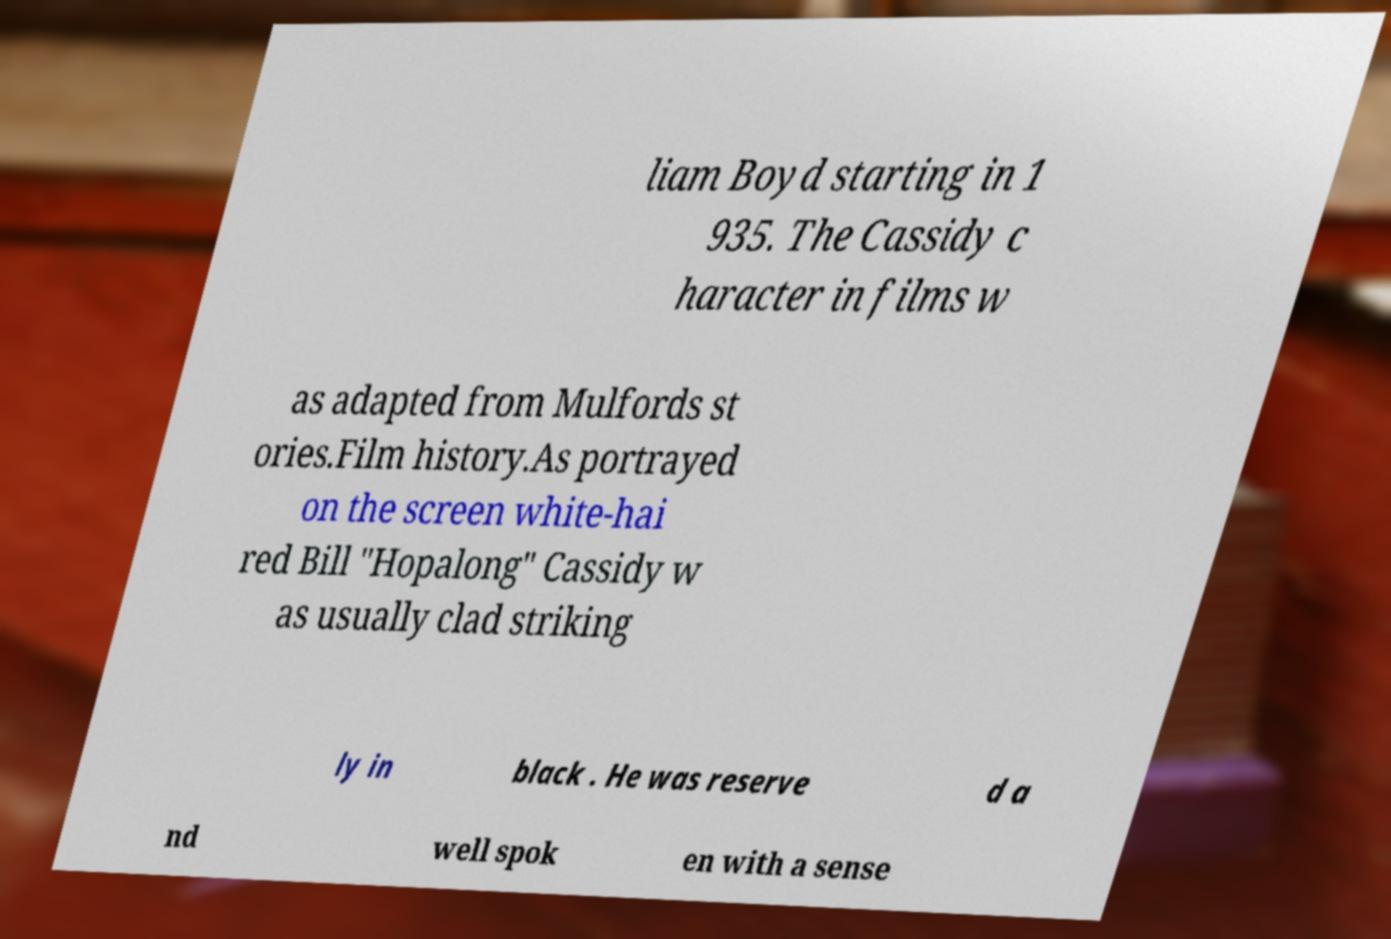Can you read and provide the text displayed in the image?This photo seems to have some interesting text. Can you extract and type it out for me? liam Boyd starting in 1 935. The Cassidy c haracter in films w as adapted from Mulfords st ories.Film history.As portrayed on the screen white-hai red Bill "Hopalong" Cassidy w as usually clad striking ly in black . He was reserve d a nd well spok en with a sense 